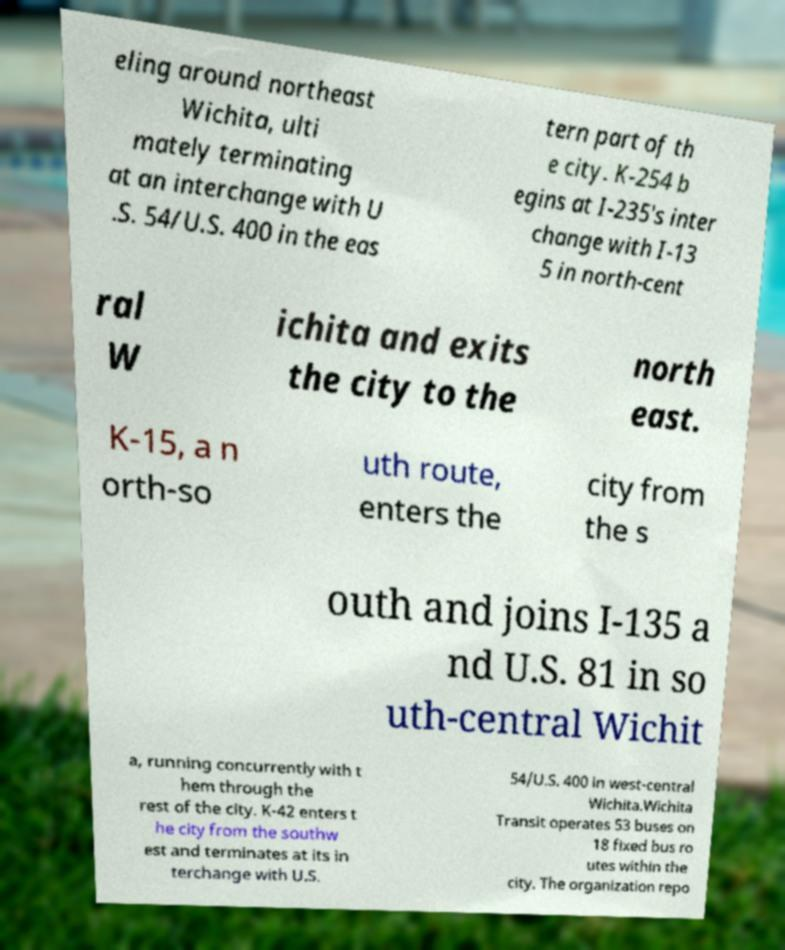Please identify and transcribe the text found in this image. eling around northeast Wichita, ulti mately terminating at an interchange with U .S. 54/U.S. 400 in the eas tern part of th e city. K-254 b egins at I-235's inter change with I-13 5 in north-cent ral W ichita and exits the city to the north east. K-15, a n orth-so uth route, enters the city from the s outh and joins I-135 a nd U.S. 81 in so uth-central Wichit a, running concurrently with t hem through the rest of the city. K-42 enters t he city from the southw est and terminates at its in terchange with U.S. 54/U.S. 400 in west-central Wichita.Wichita Transit operates 53 buses on 18 fixed bus ro utes within the city. The organization repo 